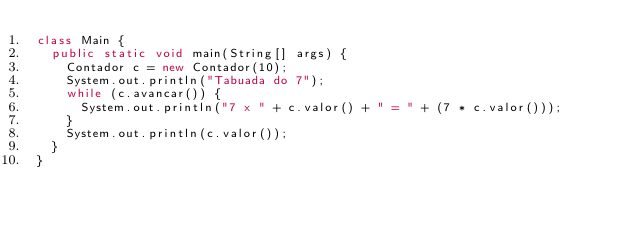Convert code to text. <code><loc_0><loc_0><loc_500><loc_500><_Java_>class Main {
  public static void main(String[] args) {
    Contador c = new Contador(10);
    System.out.println("Tabuada do 7");
    while (c.avancar()) {
      System.out.println("7 x " + c.valor() + " = " + (7 * c.valor()));
    }
    System.out.println(c.valor());
  }
}
</code> 